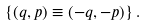Convert formula to latex. <formula><loc_0><loc_0><loc_500><loc_500>\{ ( q , p ) \equiv ( - q , - p ) \} \, .</formula> 